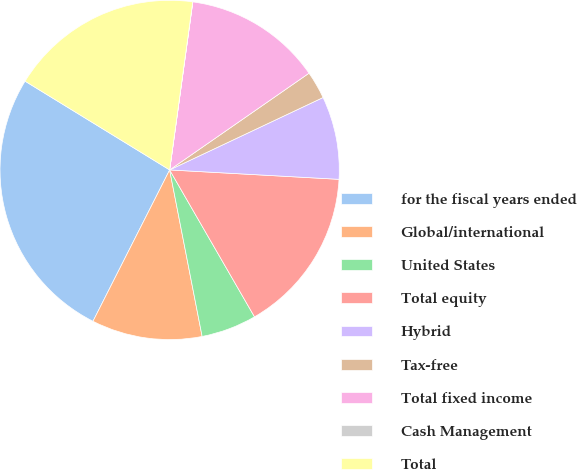Convert chart. <chart><loc_0><loc_0><loc_500><loc_500><pie_chart><fcel>for the fiscal years ended<fcel>Global/international<fcel>United States<fcel>Total equity<fcel>Hybrid<fcel>Tax-free<fcel>Total fixed income<fcel>Cash Management<fcel>Total<nl><fcel>26.3%<fcel>10.53%<fcel>5.27%<fcel>15.78%<fcel>7.9%<fcel>2.64%<fcel>13.16%<fcel>0.01%<fcel>18.41%<nl></chart> 